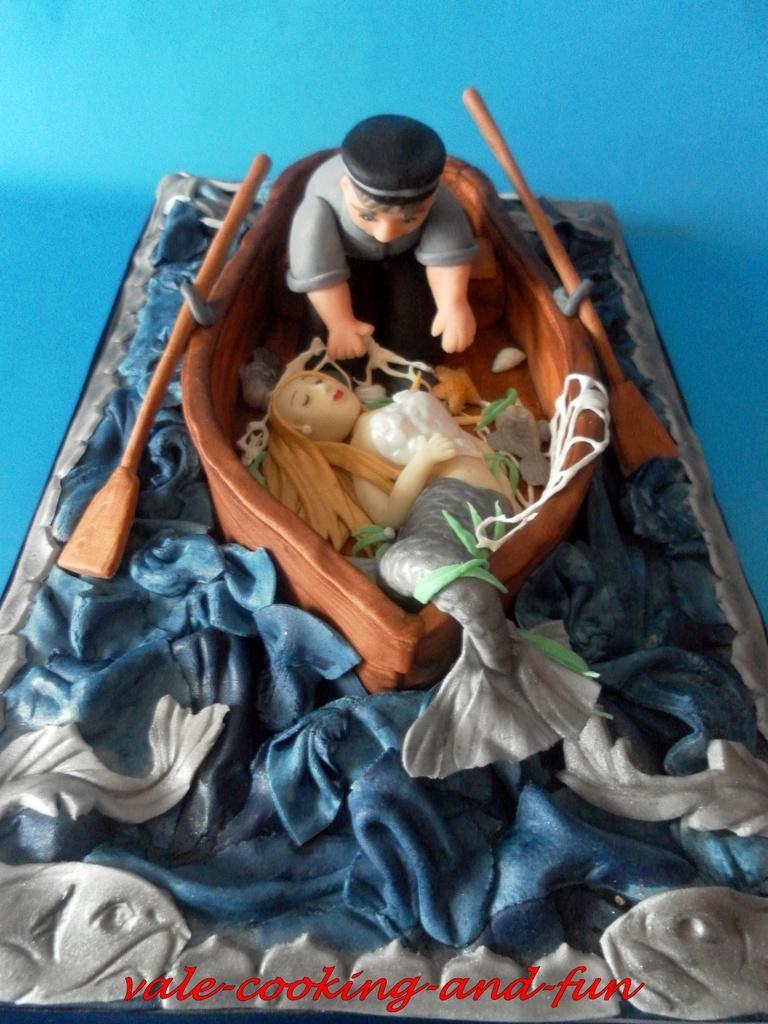How would you summarize this image in a sentence or two? This is the image of a toy. In this we can see rows, boat, mermaid and a man. 